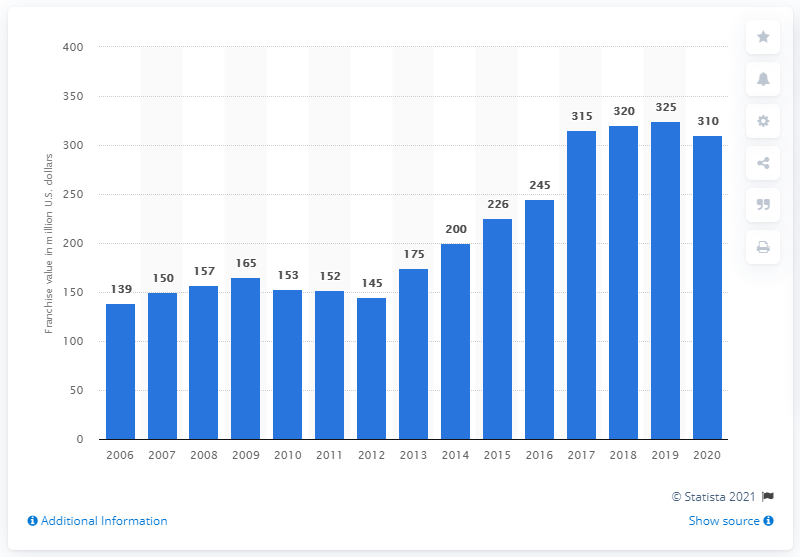What was the value of the Columbus Blue Jackets franchise in dollars in 2020? In 2020, the Columbus Blue Jackets franchise was valued at 310 million dollars. The graph shows a general upward trend in the franchise's value over the years, peaking at 325 million dollars in 2019 before slightly declining. 